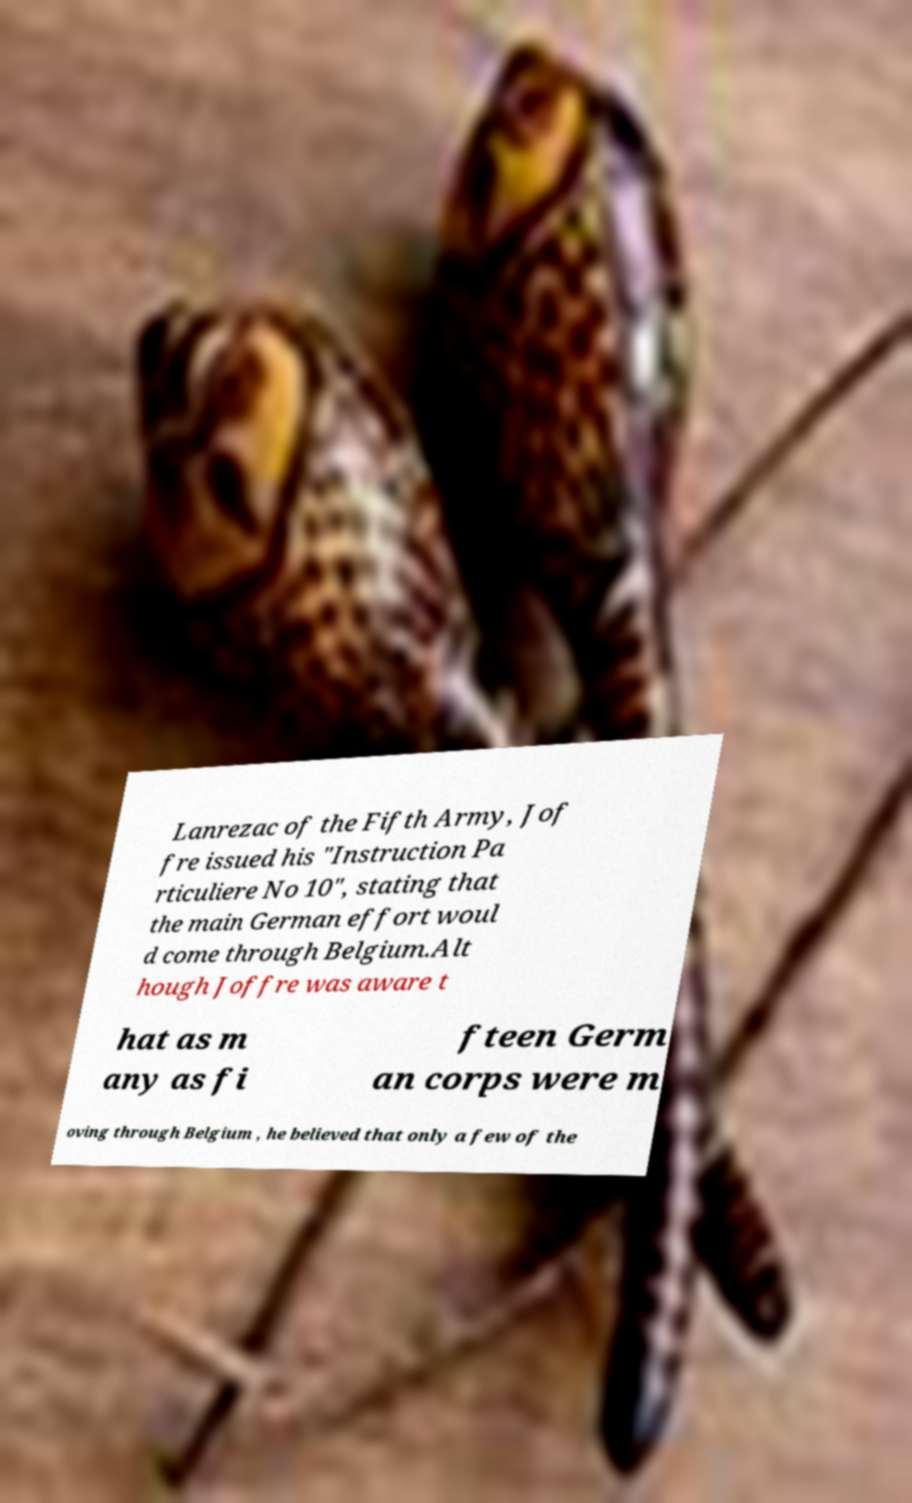Please identify and transcribe the text found in this image. Lanrezac of the Fifth Army, Jof fre issued his "Instruction Pa rticuliere No 10", stating that the main German effort woul d come through Belgium.Alt hough Joffre was aware t hat as m any as fi fteen Germ an corps were m oving through Belgium , he believed that only a few of the 